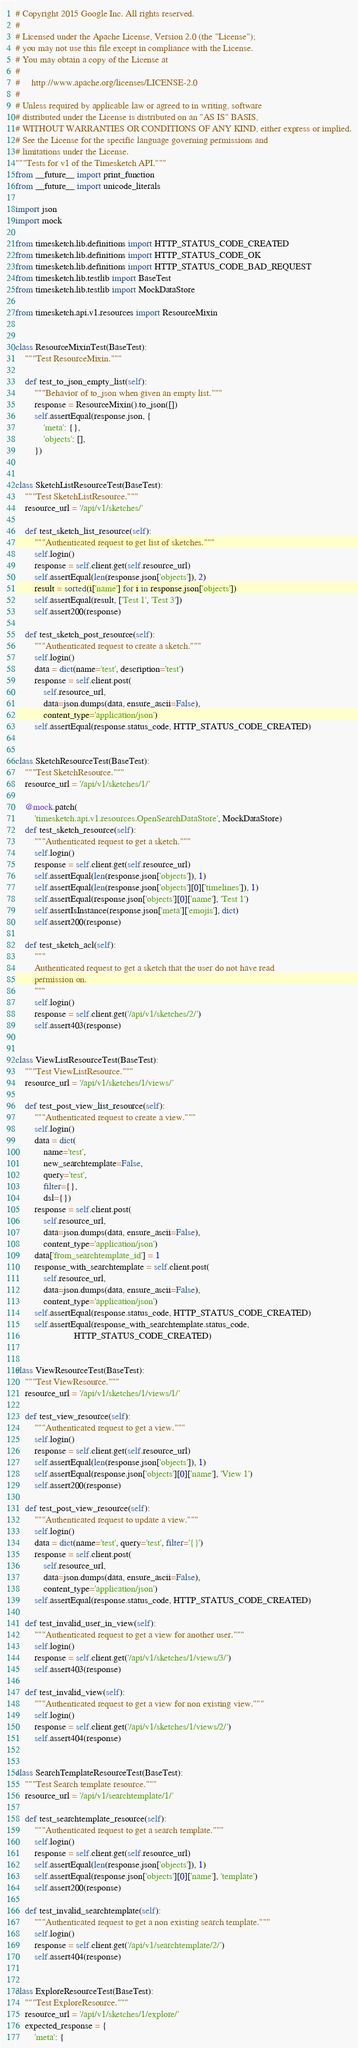Convert code to text. <code><loc_0><loc_0><loc_500><loc_500><_Python_># Copyright 2015 Google Inc. All rights reserved.
#
# Licensed under the Apache License, Version 2.0 (the "License");
# you may not use this file except in compliance with the License.
# You may obtain a copy of the License at
#
#     http://www.apache.org/licenses/LICENSE-2.0
#
# Unless required by applicable law or agreed to in writing, software
# distributed under the License is distributed on an "AS IS" BASIS,
# WITHOUT WARRANTIES OR CONDITIONS OF ANY KIND, either express or implied.
# See the License for the specific language governing permissions and
# limitations under the License.
"""Tests for v1 of the Timesketch API."""
from __future__ import print_function
from __future__ import unicode_literals

import json
import mock

from timesketch.lib.definitions import HTTP_STATUS_CODE_CREATED
from timesketch.lib.definitions import HTTP_STATUS_CODE_OK
from timesketch.lib.definitions import HTTP_STATUS_CODE_BAD_REQUEST
from timesketch.lib.testlib import BaseTest
from timesketch.lib.testlib import MockDataStore

from timesketch.api.v1.resources import ResourceMixin


class ResourceMixinTest(BaseTest):
    """Test ResourceMixin."""

    def test_to_json_empty_list(self):
        """Behavior of to_json when given an empty list."""
        response = ResourceMixin().to_json([])
        self.assertEqual(response.json, {
            'meta': {},
            'objects': [],
        })


class SketchListResourceTest(BaseTest):
    """Test SketchListResource."""
    resource_url = '/api/v1/sketches/'

    def test_sketch_list_resource(self):
        """Authenticated request to get list of sketches."""
        self.login()
        response = self.client.get(self.resource_url)
        self.assertEqual(len(response.json['objects']), 2)
        result = sorted(i['name'] for i in response.json['objects'])
        self.assertEqual(result, ['Test 1', 'Test 3'])
        self.assert200(response)

    def test_sketch_post_resource(self):
        """Authenticated request to create a sketch."""
        self.login()
        data = dict(name='test', description='test')
        response = self.client.post(
            self.resource_url,
            data=json.dumps(data, ensure_ascii=False),
            content_type='application/json')
        self.assertEqual(response.status_code, HTTP_STATUS_CODE_CREATED)


class SketchResourceTest(BaseTest):
    """Test SketchResource."""
    resource_url = '/api/v1/sketches/1/'

    @mock.patch(
        'timesketch.api.v1.resources.OpenSearchDataStore', MockDataStore)
    def test_sketch_resource(self):
        """Authenticated request to get a sketch."""
        self.login()
        response = self.client.get(self.resource_url)
        self.assertEqual(len(response.json['objects']), 1)
        self.assertEqual(len(response.json['objects'][0]['timelines']), 1)
        self.assertEqual(response.json['objects'][0]['name'], 'Test 1')
        self.assertIsInstance(response.json['meta']['emojis'], dict)
        self.assert200(response)

    def test_sketch_acl(self):
        """
        Authenticated request to get a sketch that the user do not have read
        permission on.
        """
        self.login()
        response = self.client.get('/api/v1/sketches/2/')
        self.assert403(response)


class ViewListResourceTest(BaseTest):
    """Test ViewListResource."""
    resource_url = '/api/v1/sketches/1/views/'

    def test_post_view_list_resource(self):
        """Authenticated request to create a view."""
        self.login()
        data = dict(
            name='test',
            new_searchtemplate=False,
            query='test',
            filter={},
            dsl={})
        response = self.client.post(
            self.resource_url,
            data=json.dumps(data, ensure_ascii=False),
            content_type='application/json')
        data['from_searchtemplate_id'] = 1
        response_with_searchtemplate = self.client.post(
            self.resource_url,
            data=json.dumps(data, ensure_ascii=False),
            content_type='application/json')
        self.assertEqual(response.status_code, HTTP_STATUS_CODE_CREATED)
        self.assertEqual(response_with_searchtemplate.status_code,
                         HTTP_STATUS_CODE_CREATED)


class ViewResourceTest(BaseTest):
    """Test ViewResource."""
    resource_url = '/api/v1/sketches/1/views/1/'

    def test_view_resource(self):
        """Authenticated request to get a view."""
        self.login()
        response = self.client.get(self.resource_url)
        self.assertEqual(len(response.json['objects']), 1)
        self.assertEqual(response.json['objects'][0]['name'], 'View 1')
        self.assert200(response)

    def test_post_view_resource(self):
        """Authenticated request to update a view."""
        self.login()
        data = dict(name='test', query='test', filter='{}')
        response = self.client.post(
            self.resource_url,
            data=json.dumps(data, ensure_ascii=False),
            content_type='application/json')
        self.assertEqual(response.status_code, HTTP_STATUS_CODE_CREATED)

    def test_invalid_user_in_view(self):
        """Authenticated request to get a view for another user."""
        self.login()
        response = self.client.get('/api/v1/sketches/1/views/3/')
        self.assert403(response)

    def test_invalid_view(self):
        """Authenticated request to get a view for non existing view."""
        self.login()
        response = self.client.get('/api/v1/sketches/1/views/2/')
        self.assert404(response)


class SearchTemplateResourceTest(BaseTest):
    """Test Search template resource."""
    resource_url = '/api/v1/searchtemplate/1/'

    def test_searchtemplate_resource(self):
        """Authenticated request to get a search template."""
        self.login()
        response = self.client.get(self.resource_url)
        self.assertEqual(len(response.json['objects']), 1)
        self.assertEqual(response.json['objects'][0]['name'], 'template')
        self.assert200(response)

    def test_invalid_searchtemplate(self):
        """Authenticated request to get a non existing search template."""
        self.login()
        response = self.client.get('/api/v1/searchtemplate/2/')
        self.assert404(response)


class ExploreResourceTest(BaseTest):
    """Test ExploreResource."""
    resource_url = '/api/v1/sketches/1/explore/'
    expected_response = {
        'meta': {</code> 